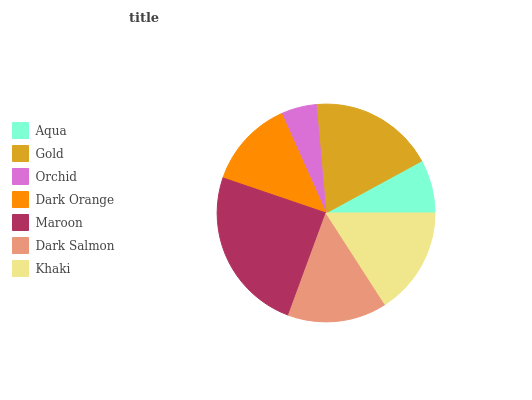Is Orchid the minimum?
Answer yes or no. Yes. Is Maroon the maximum?
Answer yes or no. Yes. Is Gold the minimum?
Answer yes or no. No. Is Gold the maximum?
Answer yes or no. No. Is Gold greater than Aqua?
Answer yes or no. Yes. Is Aqua less than Gold?
Answer yes or no. Yes. Is Aqua greater than Gold?
Answer yes or no. No. Is Gold less than Aqua?
Answer yes or no. No. Is Dark Salmon the high median?
Answer yes or no. Yes. Is Dark Salmon the low median?
Answer yes or no. Yes. Is Khaki the high median?
Answer yes or no. No. Is Dark Orange the low median?
Answer yes or no. No. 